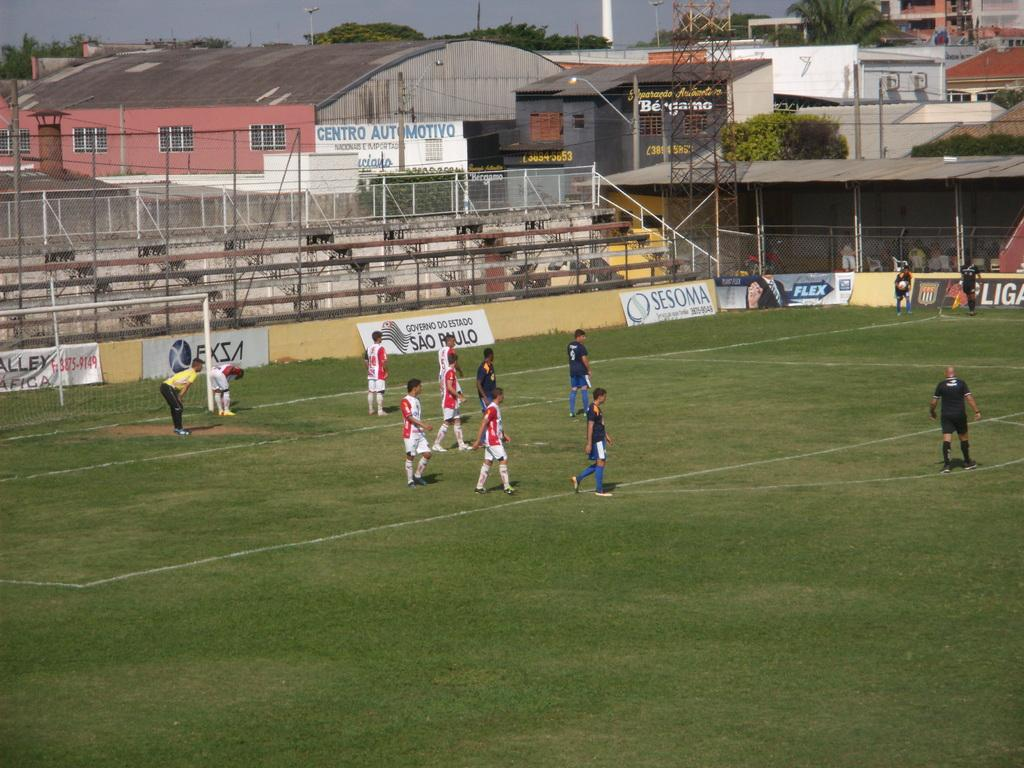<image>
Summarize the visual content of the image. people on a field playing sports in front of ads like Sesoma 